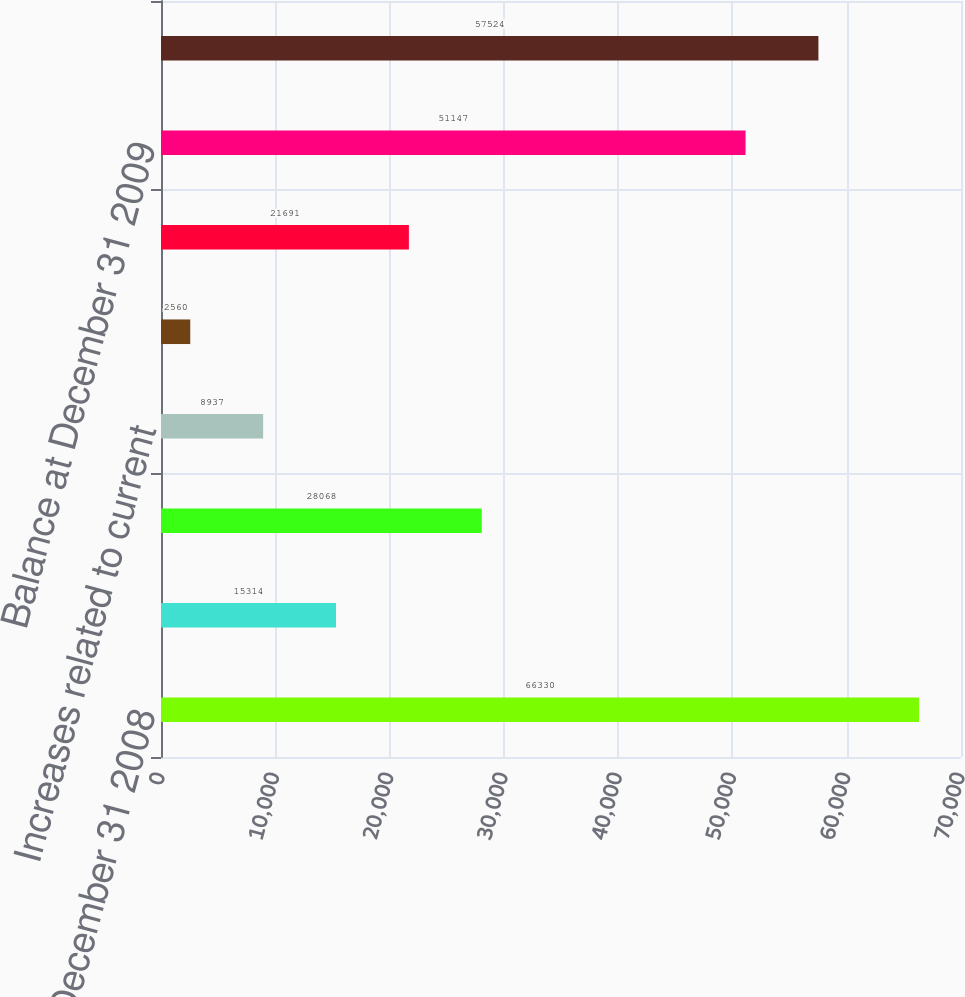Convert chart to OTSL. <chart><loc_0><loc_0><loc_500><loc_500><bar_chart><fcel>Balance at December 31 2008<fcel>Increases related to prior<fcel>Decreases related to prior<fcel>Increases related to current<fcel>Settlements during the period<fcel>Lapses of applicable statute<fcel>Balance at December 31 2009<fcel>Balance at December 31 2010<nl><fcel>66330<fcel>15314<fcel>28068<fcel>8937<fcel>2560<fcel>21691<fcel>51147<fcel>57524<nl></chart> 